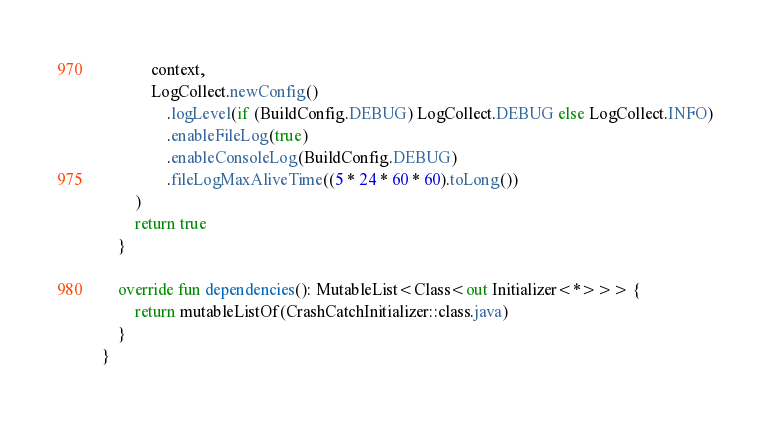Convert code to text. <code><loc_0><loc_0><loc_500><loc_500><_Kotlin_>            context,
            LogCollect.newConfig()
                .logLevel(if (BuildConfig.DEBUG) LogCollect.DEBUG else LogCollect.INFO)
                .enableFileLog(true)
                .enableConsoleLog(BuildConfig.DEBUG)
                .fileLogMaxAliveTime((5 * 24 * 60 * 60).toLong())
        )
        return true
    }

    override fun dependencies(): MutableList<Class<out Initializer<*>>> {
        return mutableListOf(CrashCatchInitializer::class.java)
    }
}</code> 